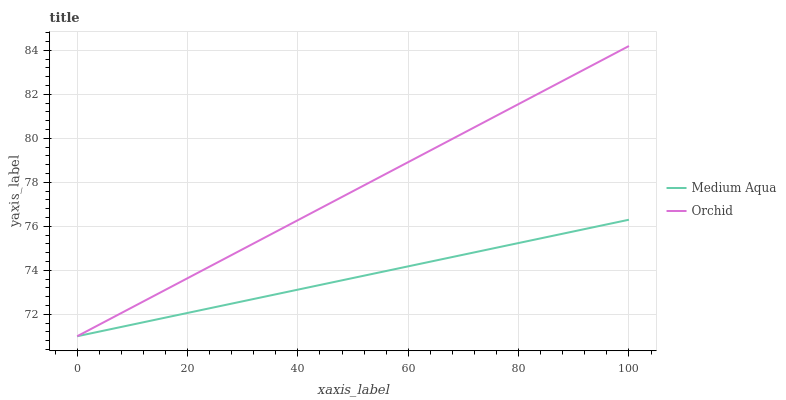Does Medium Aqua have the minimum area under the curve?
Answer yes or no. Yes. Does Orchid have the maximum area under the curve?
Answer yes or no. Yes. Does Orchid have the minimum area under the curve?
Answer yes or no. No. Is Medium Aqua the smoothest?
Answer yes or no. Yes. Is Orchid the roughest?
Answer yes or no. Yes. Is Orchid the smoothest?
Answer yes or no. No. Does Medium Aqua have the lowest value?
Answer yes or no. Yes. Does Orchid have the highest value?
Answer yes or no. Yes. Does Orchid intersect Medium Aqua?
Answer yes or no. Yes. Is Orchid less than Medium Aqua?
Answer yes or no. No. Is Orchid greater than Medium Aqua?
Answer yes or no. No. 